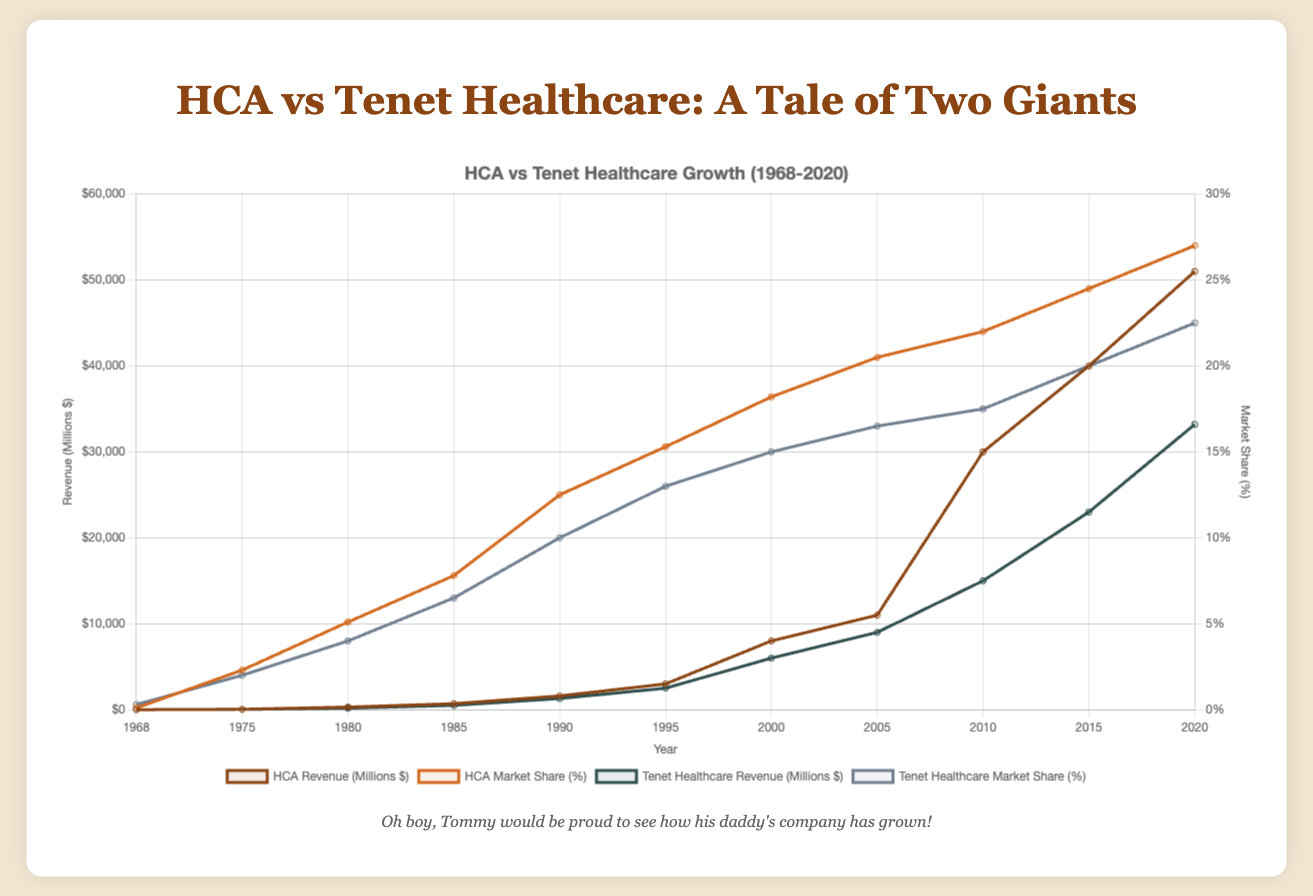how has HCA's market share changed between 1968 and 2020? To find out how HCA's market share has changed, look at the market share percentage for HCA in the years 1968 and 2020. In 1968, it was 0.1%, and in 2020, it was 27.0%. The increase is 27.0% - 0.1% = 26.9%.
Answer: 26.9% Which company had a higher revenue in 1990, HCA or Tenet Healthcare? Check the revenue figures for both companies in 1990. HCA's revenue was $1600 million, and Tenet Healthcare's revenue was $1300 million. Comparing these, HCA had the higher revenue.
Answer: HCA Between 1980 and 2000, which company had a greater percentage increase in market share? Calculate the percentage increase in market share for both companies from 1980 to 2000. For HCA: (18.2% - 5.1%) / 5.1% = 2.57 or 257%. For Tenet Healthcare: (15.0% - 4.0%) / 4.0% = 2.75 or 275%. Tenet Healthcare had a greater percentage increase.
Answer: Tenet Healthcare What is the trend of HCA's revenue growth over the years? Observe HCA's revenue figures across the given years (1968, 1975, 1980, 1985, etc.). The revenue consistently increased from $1 million in 1968 to $51000 million in 2020, showing a clear upward trend.
Answer: Upward trend In which year did Tenet Healthcare surpass a revenue of $10000 million? Examine the revenue data for Tenet Healthcare over the years. In 2005, their revenue was $9000 million, and in 2010 it jumped to $15000 million. Thus, they surpassed $10000 million in 2010.
Answer: 2010 How does HCA's market share in 2020 compare to that of Tenet Healthcare? Compare HCA's and Tenet Healthcare's market share percentages in 2020. HCA's market share was 27.0%, while Tenet Healthcare's was 22.5%. HCA's market share was higher.
Answer: HCA What is the total revenue for both companies in the year 2000? Add the revenue figures for HCA and Tenet Healthcare in 2000. HCA had $8000 million, and Tenet Healthcare had $6000 million. The total is $8000 million + $6000 million = $14000 million.
Answer: $14000 million Which company had a steeper increase in market share between 1968 and 1985? Calculate the percentage change in market share for both companies from 1968 to 1985. For HCA: (7.8% - 0.1%) / 0.1% = 7700%. For Tenet Healthcare: (6.5% - 0.3%) / 0.3% = 2066.67%. HCA had a steeper increase.
Answer: HCA What year did HCA first reach a market share of over 20%? Look at the market share data for HCA across different years and find when it exceeds 20%. In 2005, HCA's market share was 20.5%.
Answer: 2005 Which company had a more consistent growth in revenue from 1990 to 2020? Compare the revenue data's trend lines for both companies between 1990 and 2020. HCA shows a more consistent and steeper growth curve compared to some dips and slower growth in Tenet Healthcare's curve.
Answer: HCA 